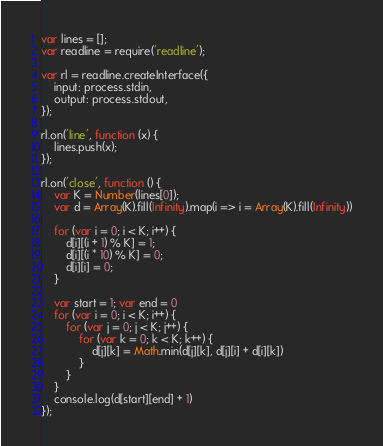<code> <loc_0><loc_0><loc_500><loc_500><_JavaScript_>var lines = [];
var readline = require('readline');

var rl = readline.createInterface({
    input: process.stdin,
    output: process.stdout,
});

rl.on('line', function (x) {
    lines.push(x);
});

rl.on('close', function () {
    var K = Number(lines[0]);
    var d = Array(K).fill(Infinity).map(i => i = Array(K).fill(Infinity))

    for (var i = 0; i < K; i++) {
        d[i][(i + 1) % K] = 1;
        d[i][(i * 10) % K] = 0;
        d[i][i] = 0;
    }

    var start = 1; var end = 0
    for (var i = 0; i < K; i++) {
        for (var j = 0; j < K; j++) {
            for (var k = 0; k < K; k++) {
                d[j][k] = Math.min(d[j][k], d[j][i] + d[i][k])
            }
        }
    }
    console.log(d[start][end] + 1)
});
</code> 